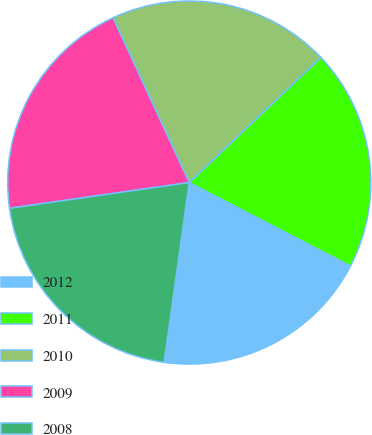Convert chart. <chart><loc_0><loc_0><loc_500><loc_500><pie_chart><fcel>2012<fcel>2011<fcel>2010<fcel>2009<fcel>2008<nl><fcel>19.61%<fcel>19.7%<fcel>19.8%<fcel>20.37%<fcel>20.52%<nl></chart> 